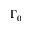<formula> <loc_0><loc_0><loc_500><loc_500>\Gamma _ { 0 }</formula> 